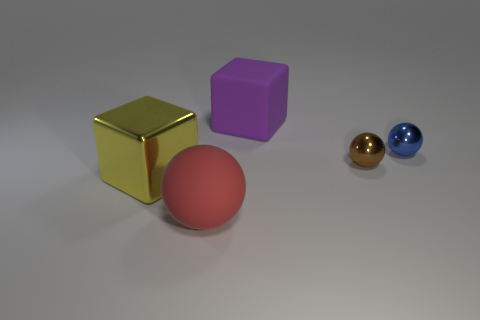Which object in the image might feel heaviest to lift and why? Though it's difficult to ascertain weight through visual assessment alone, the large sphere might feel the heaviest to lift given its size relative to the other objects; in reality, the actual weight would depend on the material each object is made from. 